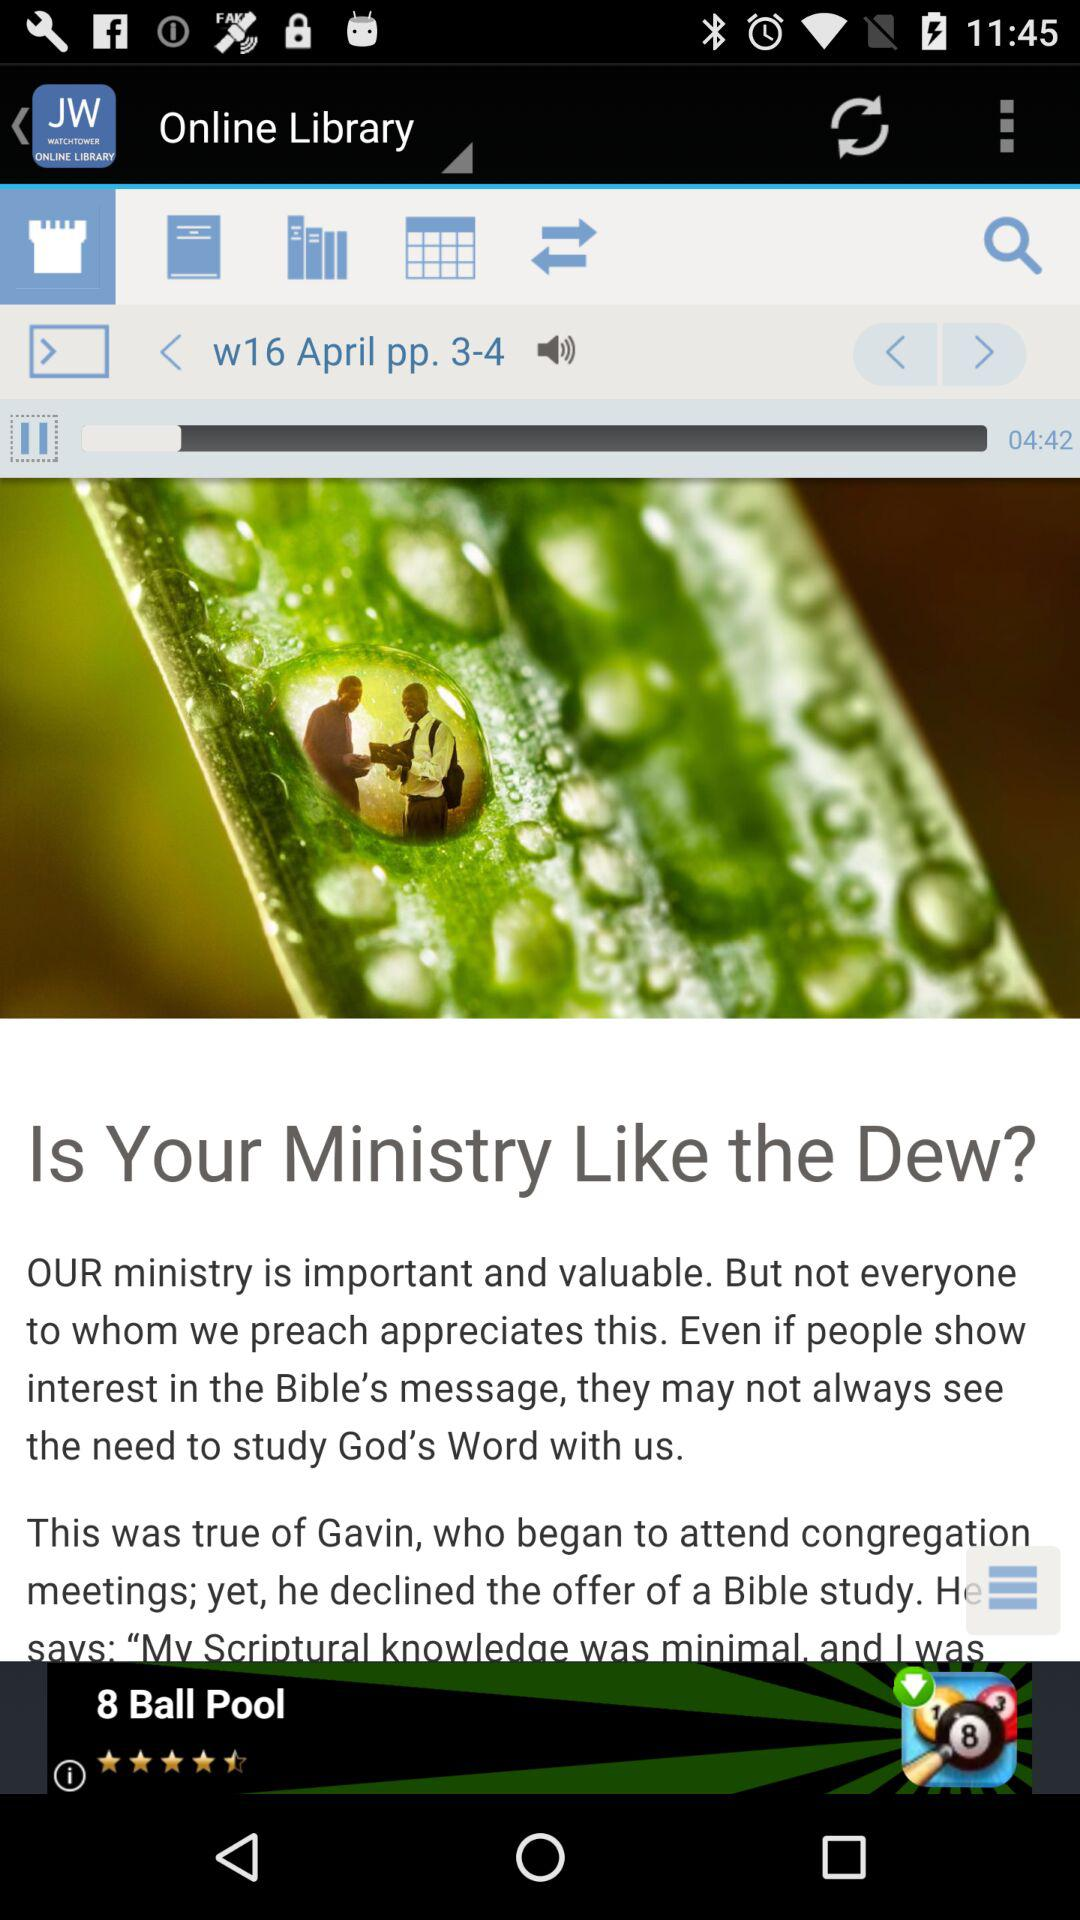What is the posted date of the article? The posted date of the article is April 16. 